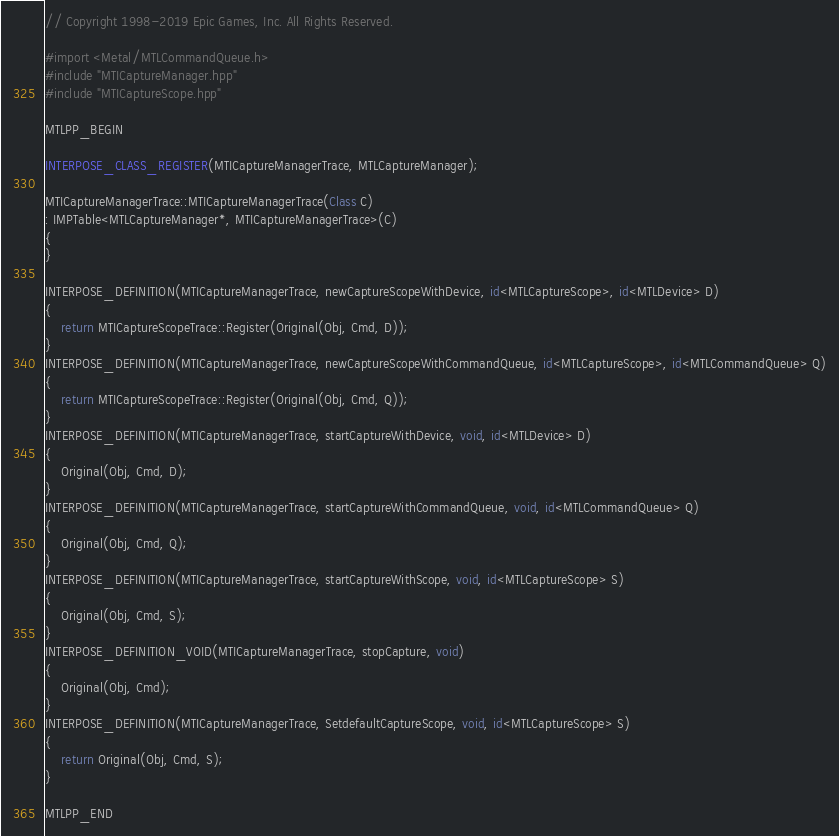<code> <loc_0><loc_0><loc_500><loc_500><_ObjectiveC_>// Copyright 1998-2019 Epic Games, Inc. All Rights Reserved.

#import <Metal/MTLCommandQueue.h>
#include "MTICaptureManager.hpp"
#include "MTICaptureScope.hpp"

MTLPP_BEGIN

INTERPOSE_CLASS_REGISTER(MTICaptureManagerTrace, MTLCaptureManager);

MTICaptureManagerTrace::MTICaptureManagerTrace(Class C)
: IMPTable<MTLCaptureManager*, MTICaptureManagerTrace>(C)
{
}

INTERPOSE_DEFINITION(MTICaptureManagerTrace, newCaptureScopeWithDevice, id<MTLCaptureScope>, id<MTLDevice> D)
{
	return MTICaptureScopeTrace::Register(Original(Obj, Cmd, D));
}
INTERPOSE_DEFINITION(MTICaptureManagerTrace, newCaptureScopeWithCommandQueue, id<MTLCaptureScope>, id<MTLCommandQueue> Q)
{
	return MTICaptureScopeTrace::Register(Original(Obj, Cmd, Q));
}
INTERPOSE_DEFINITION(MTICaptureManagerTrace, startCaptureWithDevice, void, id<MTLDevice> D)
{
	Original(Obj, Cmd, D);
}
INTERPOSE_DEFINITION(MTICaptureManagerTrace, startCaptureWithCommandQueue, void, id<MTLCommandQueue> Q)
{
	Original(Obj, Cmd, Q);
}
INTERPOSE_DEFINITION(MTICaptureManagerTrace, startCaptureWithScope, void, id<MTLCaptureScope> S)
{
	Original(Obj, Cmd, S);
}
INTERPOSE_DEFINITION_VOID(MTICaptureManagerTrace, stopCapture, void)
{
	Original(Obj, Cmd);
}
INTERPOSE_DEFINITION(MTICaptureManagerTrace, SetdefaultCaptureScope, void, id<MTLCaptureScope> S)
{
	return Original(Obj, Cmd, S);
}

MTLPP_END
</code> 